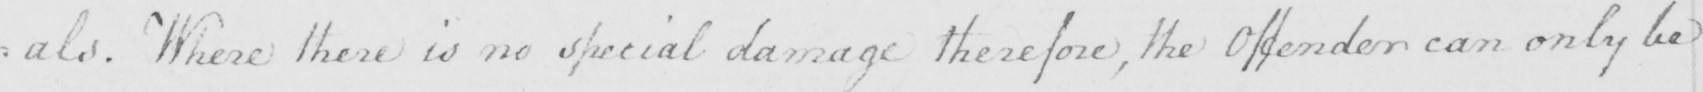What is written in this line of handwriting? : als . Where there is no special damage therefore , the Offender can only be 